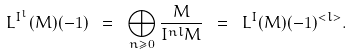Convert formula to latex. <formula><loc_0><loc_0><loc_500><loc_500>L ^ { I ^ { l } } ( M ) ( - 1 ) \ = \ \bigoplus _ { n \geq 0 } \frac { M } { I ^ { n l } M } \ = \ L ^ { I } ( M ) ( - 1 ) ^ { < l > } .</formula> 